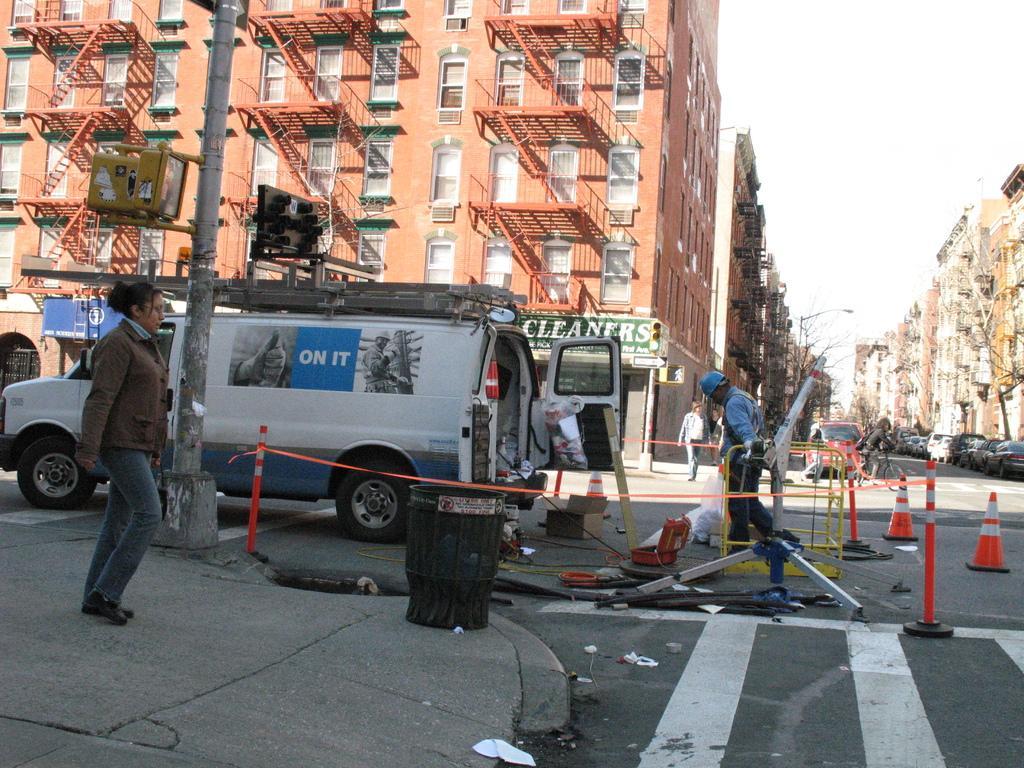What can be seen on the road in the image? There are vehicles on the road in the image. Are there any people present in the image? Yes, there are people visible in the image. What can be seen in the distance in the image? There are buildings in the background of the image. What type of zephyr can be seen blowing through the image? There is no zephyr present in the image; it is a term used to describe a gentle breeze, which cannot be seen. What smell is associated with the image? The image does not convey any specific smell, as it is a visual medium. 